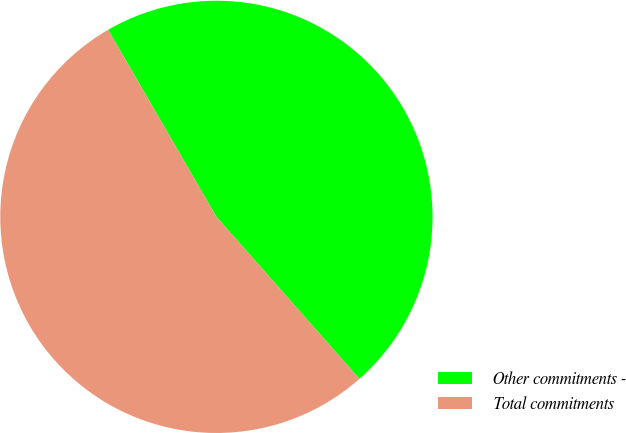Convert chart. <chart><loc_0><loc_0><loc_500><loc_500><pie_chart><fcel>Other commitments -<fcel>Total commitments<nl><fcel>46.84%<fcel>53.16%<nl></chart> 